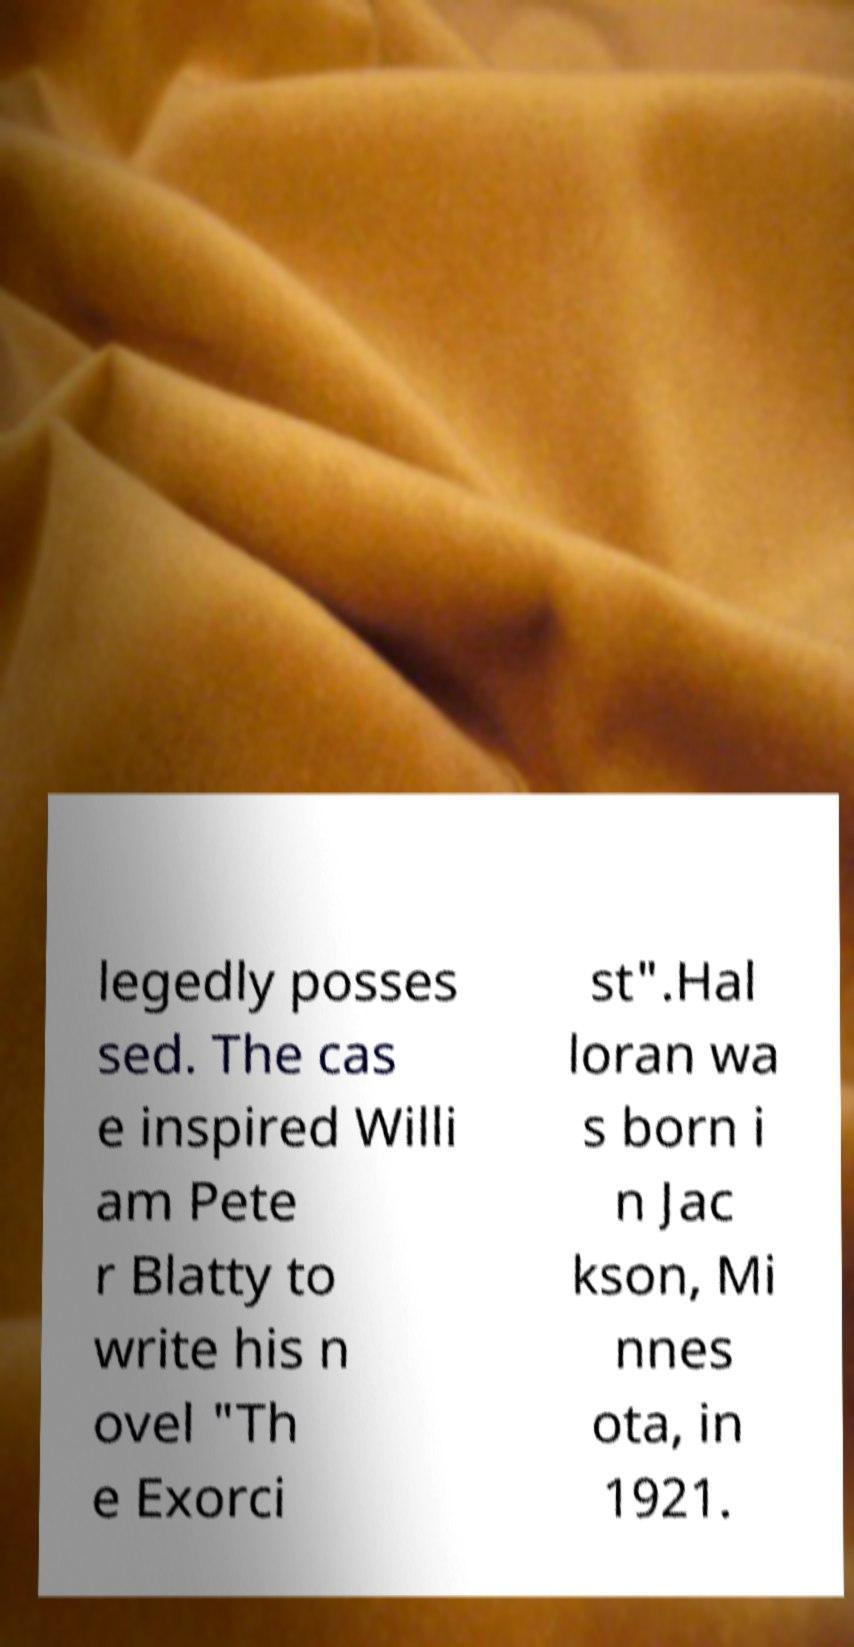Can you read and provide the text displayed in the image?This photo seems to have some interesting text. Can you extract and type it out for me? legedly posses sed. The cas e inspired Willi am Pete r Blatty to write his n ovel "Th e Exorci st".Hal loran wa s born i n Jac kson, Mi nnes ota, in 1921. 